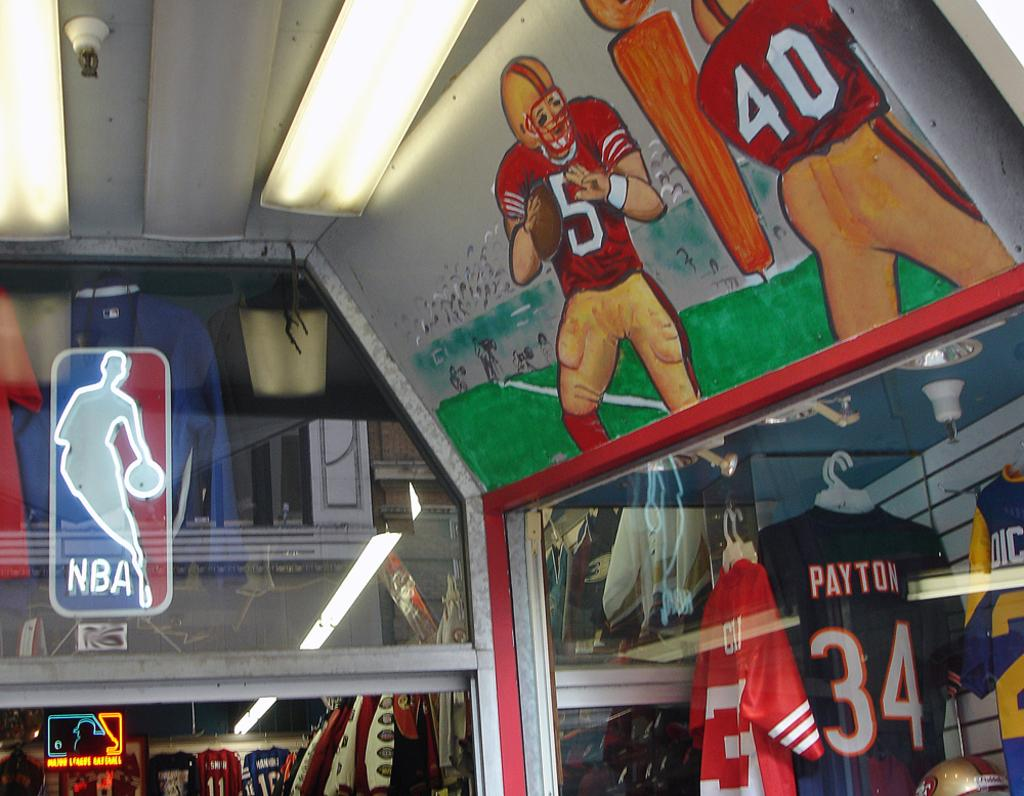Provide a one-sentence caption for the provided image. Walter Payton's number 34 jersey is one of many available at the store. 